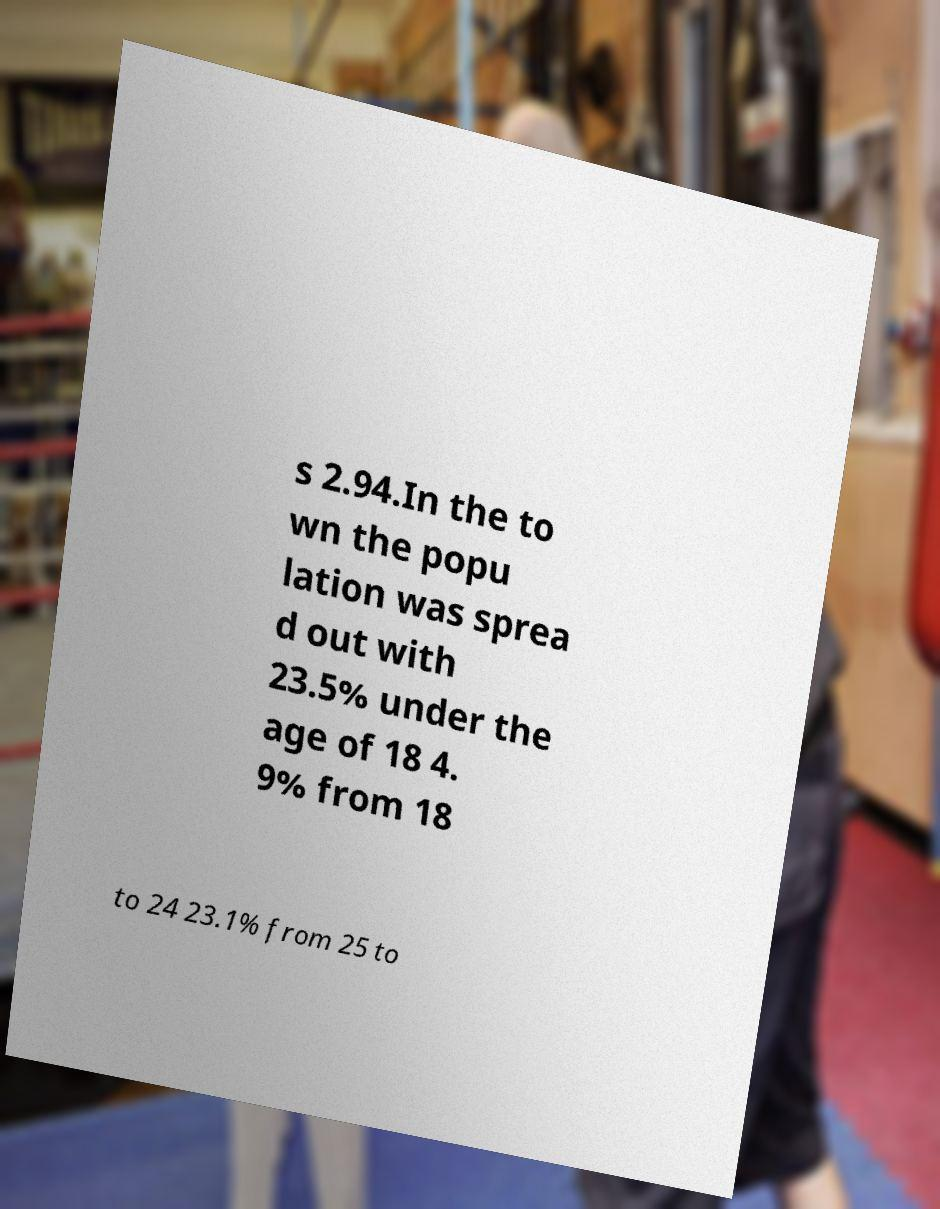Please read and relay the text visible in this image. What does it say? s 2.94.In the to wn the popu lation was sprea d out with 23.5% under the age of 18 4. 9% from 18 to 24 23.1% from 25 to 